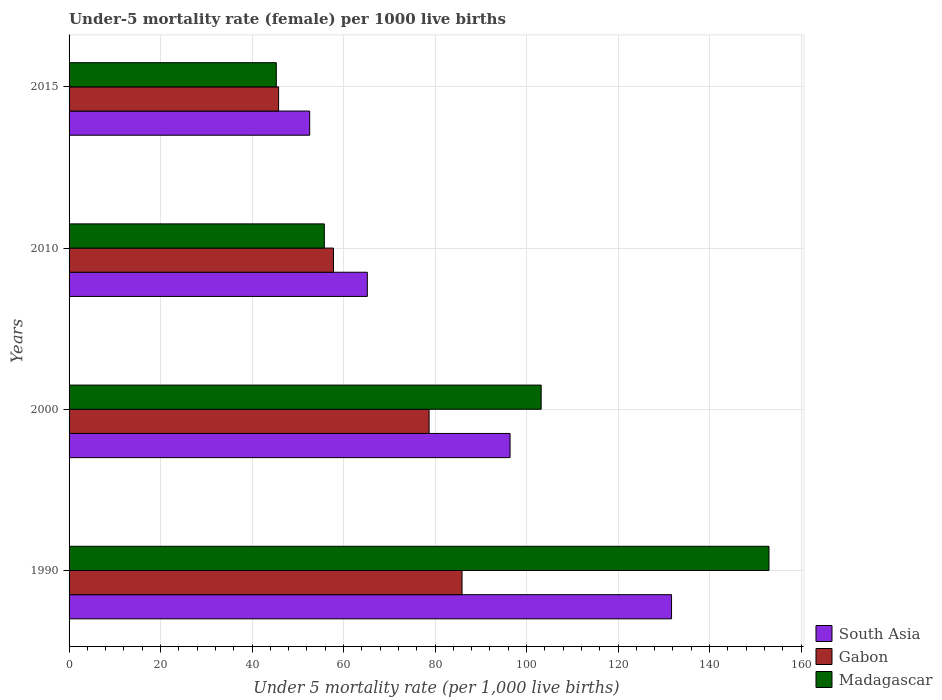How many groups of bars are there?
Offer a very short reply. 4. Are the number of bars per tick equal to the number of legend labels?
Ensure brevity in your answer.  Yes. Are the number of bars on each tick of the Y-axis equal?
Keep it short and to the point. Yes. How many bars are there on the 4th tick from the bottom?
Your response must be concise. 3. What is the label of the 1st group of bars from the top?
Ensure brevity in your answer.  2015. What is the under-five mortality rate in Gabon in 2015?
Give a very brief answer. 45.8. Across all years, what is the maximum under-five mortality rate in Gabon?
Your answer should be very brief. 85.9. Across all years, what is the minimum under-five mortality rate in Gabon?
Keep it short and to the point. 45.8. In which year was the under-five mortality rate in Gabon maximum?
Give a very brief answer. 1990. In which year was the under-five mortality rate in Gabon minimum?
Give a very brief answer. 2015. What is the total under-five mortality rate in Madagascar in the graph?
Give a very brief answer. 357.3. What is the difference between the under-five mortality rate in South Asia in 2000 and the under-five mortality rate in Madagascar in 2015?
Your response must be concise. 51.1. What is the average under-five mortality rate in Gabon per year?
Provide a short and direct response. 67.05. In the year 1990, what is the difference between the under-five mortality rate in Gabon and under-five mortality rate in Madagascar?
Make the answer very short. -67.1. In how many years, is the under-five mortality rate in Gabon greater than 16 ?
Give a very brief answer. 4. What is the ratio of the under-five mortality rate in Madagascar in 1990 to that in 2000?
Offer a terse response. 1.48. What is the difference between the highest and the second highest under-five mortality rate in South Asia?
Offer a terse response. 35.3. What is the difference between the highest and the lowest under-five mortality rate in Gabon?
Provide a succinct answer. 40.1. What does the 1st bar from the top in 1990 represents?
Your response must be concise. Madagascar. What does the 3rd bar from the bottom in 2015 represents?
Provide a succinct answer. Madagascar. Is it the case that in every year, the sum of the under-five mortality rate in Gabon and under-five mortality rate in Madagascar is greater than the under-five mortality rate in South Asia?
Offer a terse response. Yes. Are all the bars in the graph horizontal?
Your answer should be very brief. Yes. How many years are there in the graph?
Make the answer very short. 4. What is the difference between two consecutive major ticks on the X-axis?
Give a very brief answer. 20. Does the graph contain any zero values?
Provide a short and direct response. No. How are the legend labels stacked?
Provide a short and direct response. Vertical. What is the title of the graph?
Give a very brief answer. Under-5 mortality rate (female) per 1000 live births. What is the label or title of the X-axis?
Your answer should be compact. Under 5 mortality rate (per 1,0 live births). What is the Under 5 mortality rate (per 1,000 live births) of South Asia in 1990?
Ensure brevity in your answer.  131.7. What is the Under 5 mortality rate (per 1,000 live births) of Gabon in 1990?
Your answer should be compact. 85.9. What is the Under 5 mortality rate (per 1,000 live births) of Madagascar in 1990?
Your answer should be very brief. 153. What is the Under 5 mortality rate (per 1,000 live births) of South Asia in 2000?
Give a very brief answer. 96.4. What is the Under 5 mortality rate (per 1,000 live births) of Gabon in 2000?
Keep it short and to the point. 78.7. What is the Under 5 mortality rate (per 1,000 live births) in Madagascar in 2000?
Your response must be concise. 103.2. What is the Under 5 mortality rate (per 1,000 live births) in South Asia in 2010?
Keep it short and to the point. 65.2. What is the Under 5 mortality rate (per 1,000 live births) of Gabon in 2010?
Ensure brevity in your answer.  57.8. What is the Under 5 mortality rate (per 1,000 live births) of Madagascar in 2010?
Provide a succinct answer. 55.8. What is the Under 5 mortality rate (per 1,000 live births) of South Asia in 2015?
Provide a succinct answer. 52.6. What is the Under 5 mortality rate (per 1,000 live births) of Gabon in 2015?
Make the answer very short. 45.8. What is the Under 5 mortality rate (per 1,000 live births) in Madagascar in 2015?
Provide a succinct answer. 45.3. Across all years, what is the maximum Under 5 mortality rate (per 1,000 live births) of South Asia?
Your answer should be compact. 131.7. Across all years, what is the maximum Under 5 mortality rate (per 1,000 live births) in Gabon?
Your response must be concise. 85.9. Across all years, what is the maximum Under 5 mortality rate (per 1,000 live births) in Madagascar?
Your answer should be very brief. 153. Across all years, what is the minimum Under 5 mortality rate (per 1,000 live births) in South Asia?
Give a very brief answer. 52.6. Across all years, what is the minimum Under 5 mortality rate (per 1,000 live births) in Gabon?
Your response must be concise. 45.8. Across all years, what is the minimum Under 5 mortality rate (per 1,000 live births) in Madagascar?
Your answer should be compact. 45.3. What is the total Under 5 mortality rate (per 1,000 live births) in South Asia in the graph?
Provide a short and direct response. 345.9. What is the total Under 5 mortality rate (per 1,000 live births) of Gabon in the graph?
Provide a succinct answer. 268.2. What is the total Under 5 mortality rate (per 1,000 live births) of Madagascar in the graph?
Offer a terse response. 357.3. What is the difference between the Under 5 mortality rate (per 1,000 live births) of South Asia in 1990 and that in 2000?
Offer a very short reply. 35.3. What is the difference between the Under 5 mortality rate (per 1,000 live births) of Gabon in 1990 and that in 2000?
Offer a terse response. 7.2. What is the difference between the Under 5 mortality rate (per 1,000 live births) of Madagascar in 1990 and that in 2000?
Your response must be concise. 49.8. What is the difference between the Under 5 mortality rate (per 1,000 live births) in South Asia in 1990 and that in 2010?
Your response must be concise. 66.5. What is the difference between the Under 5 mortality rate (per 1,000 live births) in Gabon in 1990 and that in 2010?
Keep it short and to the point. 28.1. What is the difference between the Under 5 mortality rate (per 1,000 live births) in Madagascar in 1990 and that in 2010?
Provide a succinct answer. 97.2. What is the difference between the Under 5 mortality rate (per 1,000 live births) of South Asia in 1990 and that in 2015?
Your answer should be compact. 79.1. What is the difference between the Under 5 mortality rate (per 1,000 live births) in Gabon in 1990 and that in 2015?
Your answer should be very brief. 40.1. What is the difference between the Under 5 mortality rate (per 1,000 live births) of Madagascar in 1990 and that in 2015?
Your answer should be very brief. 107.7. What is the difference between the Under 5 mortality rate (per 1,000 live births) in South Asia in 2000 and that in 2010?
Give a very brief answer. 31.2. What is the difference between the Under 5 mortality rate (per 1,000 live births) in Gabon in 2000 and that in 2010?
Give a very brief answer. 20.9. What is the difference between the Under 5 mortality rate (per 1,000 live births) of Madagascar in 2000 and that in 2010?
Provide a short and direct response. 47.4. What is the difference between the Under 5 mortality rate (per 1,000 live births) in South Asia in 2000 and that in 2015?
Ensure brevity in your answer.  43.8. What is the difference between the Under 5 mortality rate (per 1,000 live births) in Gabon in 2000 and that in 2015?
Keep it short and to the point. 32.9. What is the difference between the Under 5 mortality rate (per 1,000 live births) of Madagascar in 2000 and that in 2015?
Provide a succinct answer. 57.9. What is the difference between the Under 5 mortality rate (per 1,000 live births) of Gabon in 2010 and that in 2015?
Offer a very short reply. 12. What is the difference between the Under 5 mortality rate (per 1,000 live births) in South Asia in 1990 and the Under 5 mortality rate (per 1,000 live births) in Gabon in 2000?
Make the answer very short. 53. What is the difference between the Under 5 mortality rate (per 1,000 live births) of Gabon in 1990 and the Under 5 mortality rate (per 1,000 live births) of Madagascar in 2000?
Make the answer very short. -17.3. What is the difference between the Under 5 mortality rate (per 1,000 live births) of South Asia in 1990 and the Under 5 mortality rate (per 1,000 live births) of Gabon in 2010?
Your response must be concise. 73.9. What is the difference between the Under 5 mortality rate (per 1,000 live births) of South Asia in 1990 and the Under 5 mortality rate (per 1,000 live births) of Madagascar in 2010?
Your response must be concise. 75.9. What is the difference between the Under 5 mortality rate (per 1,000 live births) of Gabon in 1990 and the Under 5 mortality rate (per 1,000 live births) of Madagascar in 2010?
Offer a terse response. 30.1. What is the difference between the Under 5 mortality rate (per 1,000 live births) of South Asia in 1990 and the Under 5 mortality rate (per 1,000 live births) of Gabon in 2015?
Give a very brief answer. 85.9. What is the difference between the Under 5 mortality rate (per 1,000 live births) in South Asia in 1990 and the Under 5 mortality rate (per 1,000 live births) in Madagascar in 2015?
Make the answer very short. 86.4. What is the difference between the Under 5 mortality rate (per 1,000 live births) of Gabon in 1990 and the Under 5 mortality rate (per 1,000 live births) of Madagascar in 2015?
Your response must be concise. 40.6. What is the difference between the Under 5 mortality rate (per 1,000 live births) in South Asia in 2000 and the Under 5 mortality rate (per 1,000 live births) in Gabon in 2010?
Your answer should be very brief. 38.6. What is the difference between the Under 5 mortality rate (per 1,000 live births) of South Asia in 2000 and the Under 5 mortality rate (per 1,000 live births) of Madagascar in 2010?
Your answer should be compact. 40.6. What is the difference between the Under 5 mortality rate (per 1,000 live births) of Gabon in 2000 and the Under 5 mortality rate (per 1,000 live births) of Madagascar in 2010?
Keep it short and to the point. 22.9. What is the difference between the Under 5 mortality rate (per 1,000 live births) of South Asia in 2000 and the Under 5 mortality rate (per 1,000 live births) of Gabon in 2015?
Make the answer very short. 50.6. What is the difference between the Under 5 mortality rate (per 1,000 live births) in South Asia in 2000 and the Under 5 mortality rate (per 1,000 live births) in Madagascar in 2015?
Ensure brevity in your answer.  51.1. What is the difference between the Under 5 mortality rate (per 1,000 live births) in Gabon in 2000 and the Under 5 mortality rate (per 1,000 live births) in Madagascar in 2015?
Provide a succinct answer. 33.4. What is the difference between the Under 5 mortality rate (per 1,000 live births) of Gabon in 2010 and the Under 5 mortality rate (per 1,000 live births) of Madagascar in 2015?
Your answer should be very brief. 12.5. What is the average Under 5 mortality rate (per 1,000 live births) in South Asia per year?
Your answer should be very brief. 86.47. What is the average Under 5 mortality rate (per 1,000 live births) in Gabon per year?
Offer a terse response. 67.05. What is the average Under 5 mortality rate (per 1,000 live births) in Madagascar per year?
Your answer should be very brief. 89.33. In the year 1990, what is the difference between the Under 5 mortality rate (per 1,000 live births) in South Asia and Under 5 mortality rate (per 1,000 live births) in Gabon?
Offer a terse response. 45.8. In the year 1990, what is the difference between the Under 5 mortality rate (per 1,000 live births) of South Asia and Under 5 mortality rate (per 1,000 live births) of Madagascar?
Give a very brief answer. -21.3. In the year 1990, what is the difference between the Under 5 mortality rate (per 1,000 live births) in Gabon and Under 5 mortality rate (per 1,000 live births) in Madagascar?
Your answer should be compact. -67.1. In the year 2000, what is the difference between the Under 5 mortality rate (per 1,000 live births) of South Asia and Under 5 mortality rate (per 1,000 live births) of Gabon?
Offer a very short reply. 17.7. In the year 2000, what is the difference between the Under 5 mortality rate (per 1,000 live births) of South Asia and Under 5 mortality rate (per 1,000 live births) of Madagascar?
Your response must be concise. -6.8. In the year 2000, what is the difference between the Under 5 mortality rate (per 1,000 live births) of Gabon and Under 5 mortality rate (per 1,000 live births) of Madagascar?
Ensure brevity in your answer.  -24.5. In the year 2010, what is the difference between the Under 5 mortality rate (per 1,000 live births) of South Asia and Under 5 mortality rate (per 1,000 live births) of Madagascar?
Your response must be concise. 9.4. In the year 2015, what is the difference between the Under 5 mortality rate (per 1,000 live births) in South Asia and Under 5 mortality rate (per 1,000 live births) in Gabon?
Make the answer very short. 6.8. In the year 2015, what is the difference between the Under 5 mortality rate (per 1,000 live births) in Gabon and Under 5 mortality rate (per 1,000 live births) in Madagascar?
Your response must be concise. 0.5. What is the ratio of the Under 5 mortality rate (per 1,000 live births) in South Asia in 1990 to that in 2000?
Your answer should be very brief. 1.37. What is the ratio of the Under 5 mortality rate (per 1,000 live births) in Gabon in 1990 to that in 2000?
Keep it short and to the point. 1.09. What is the ratio of the Under 5 mortality rate (per 1,000 live births) of Madagascar in 1990 to that in 2000?
Offer a terse response. 1.48. What is the ratio of the Under 5 mortality rate (per 1,000 live births) of South Asia in 1990 to that in 2010?
Ensure brevity in your answer.  2.02. What is the ratio of the Under 5 mortality rate (per 1,000 live births) of Gabon in 1990 to that in 2010?
Your answer should be very brief. 1.49. What is the ratio of the Under 5 mortality rate (per 1,000 live births) in Madagascar in 1990 to that in 2010?
Give a very brief answer. 2.74. What is the ratio of the Under 5 mortality rate (per 1,000 live births) of South Asia in 1990 to that in 2015?
Your response must be concise. 2.5. What is the ratio of the Under 5 mortality rate (per 1,000 live births) in Gabon in 1990 to that in 2015?
Provide a succinct answer. 1.88. What is the ratio of the Under 5 mortality rate (per 1,000 live births) in Madagascar in 1990 to that in 2015?
Keep it short and to the point. 3.38. What is the ratio of the Under 5 mortality rate (per 1,000 live births) of South Asia in 2000 to that in 2010?
Offer a terse response. 1.48. What is the ratio of the Under 5 mortality rate (per 1,000 live births) of Gabon in 2000 to that in 2010?
Provide a succinct answer. 1.36. What is the ratio of the Under 5 mortality rate (per 1,000 live births) in Madagascar in 2000 to that in 2010?
Provide a short and direct response. 1.85. What is the ratio of the Under 5 mortality rate (per 1,000 live births) in South Asia in 2000 to that in 2015?
Offer a terse response. 1.83. What is the ratio of the Under 5 mortality rate (per 1,000 live births) in Gabon in 2000 to that in 2015?
Provide a short and direct response. 1.72. What is the ratio of the Under 5 mortality rate (per 1,000 live births) in Madagascar in 2000 to that in 2015?
Provide a short and direct response. 2.28. What is the ratio of the Under 5 mortality rate (per 1,000 live births) in South Asia in 2010 to that in 2015?
Your answer should be compact. 1.24. What is the ratio of the Under 5 mortality rate (per 1,000 live births) in Gabon in 2010 to that in 2015?
Your answer should be very brief. 1.26. What is the ratio of the Under 5 mortality rate (per 1,000 live births) in Madagascar in 2010 to that in 2015?
Your answer should be very brief. 1.23. What is the difference between the highest and the second highest Under 5 mortality rate (per 1,000 live births) of South Asia?
Provide a short and direct response. 35.3. What is the difference between the highest and the second highest Under 5 mortality rate (per 1,000 live births) of Madagascar?
Provide a succinct answer. 49.8. What is the difference between the highest and the lowest Under 5 mortality rate (per 1,000 live births) of South Asia?
Your answer should be very brief. 79.1. What is the difference between the highest and the lowest Under 5 mortality rate (per 1,000 live births) of Gabon?
Make the answer very short. 40.1. What is the difference between the highest and the lowest Under 5 mortality rate (per 1,000 live births) in Madagascar?
Your response must be concise. 107.7. 